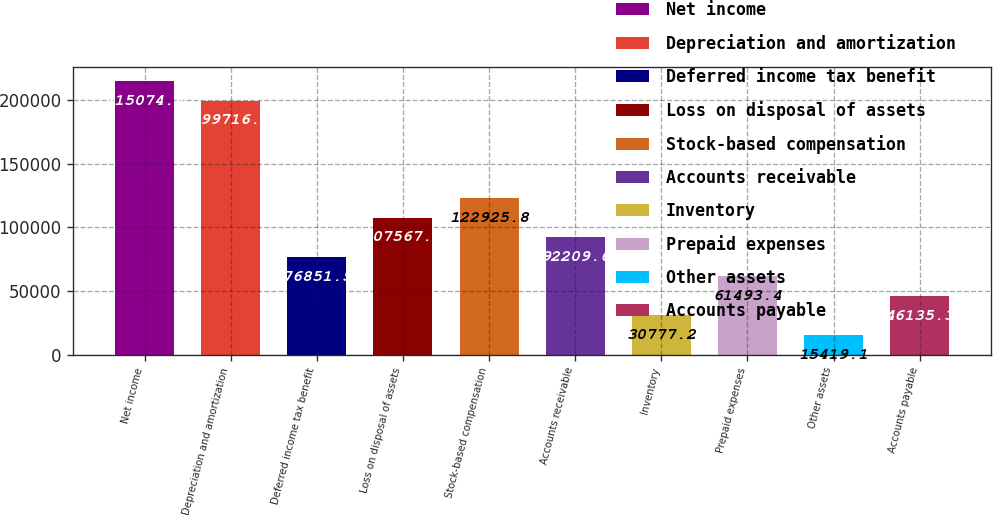Convert chart. <chart><loc_0><loc_0><loc_500><loc_500><bar_chart><fcel>Net income<fcel>Depreciation and amortization<fcel>Deferred income tax benefit<fcel>Loss on disposal of assets<fcel>Stock-based compensation<fcel>Accounts receivable<fcel>Inventory<fcel>Prepaid expenses<fcel>Other assets<fcel>Accounts payable<nl><fcel>215074<fcel>199716<fcel>76851.5<fcel>107568<fcel>122926<fcel>92209.6<fcel>30777.2<fcel>61493.4<fcel>15419.1<fcel>46135.3<nl></chart> 